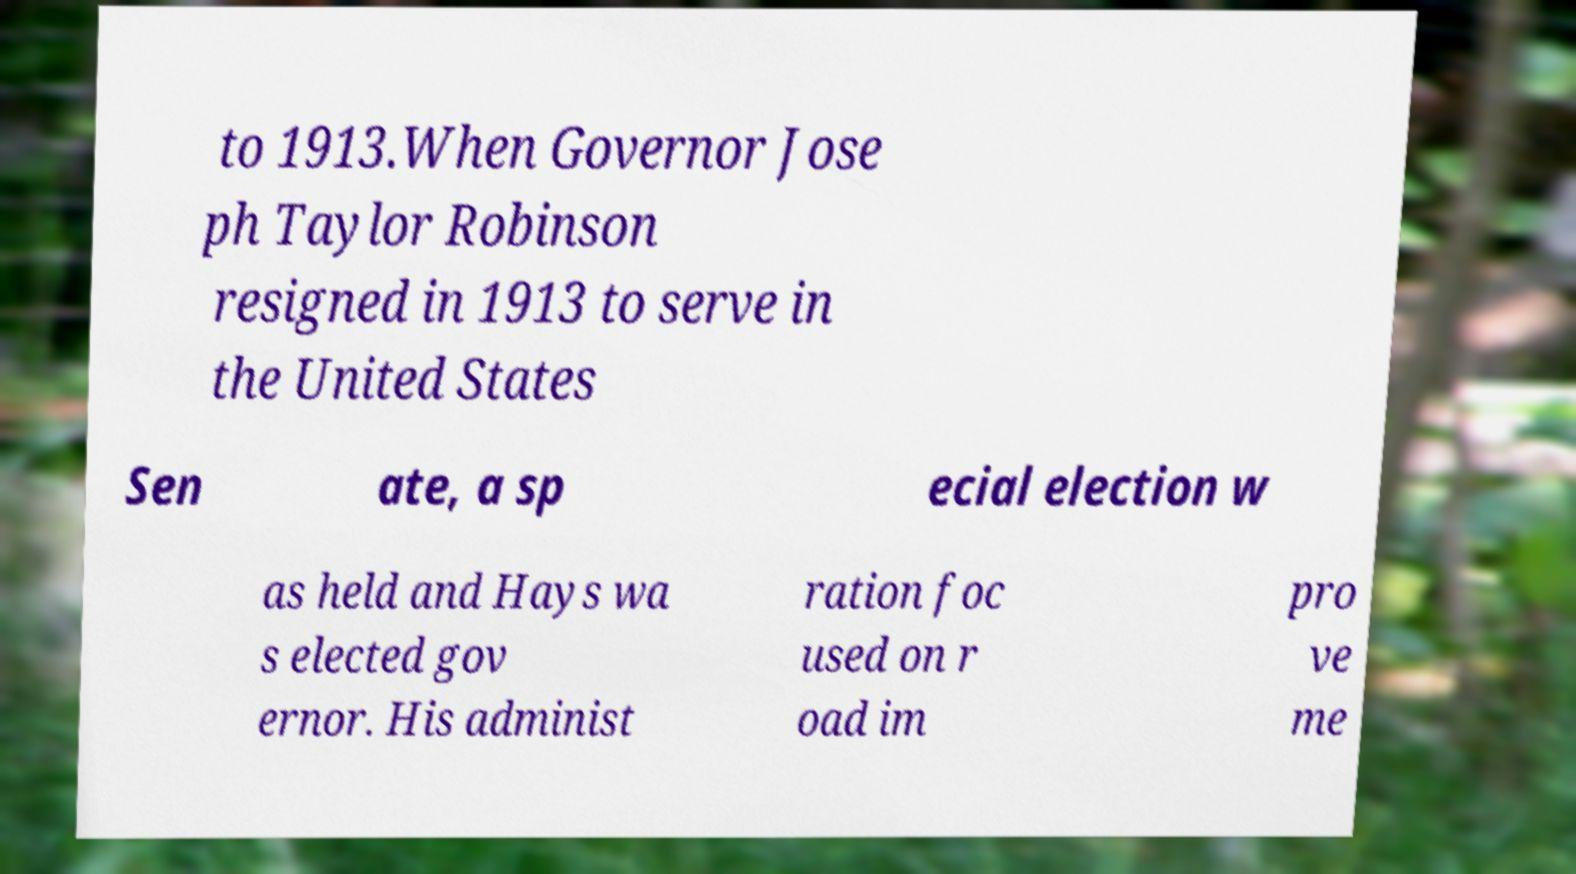Could you assist in decoding the text presented in this image and type it out clearly? to 1913.When Governor Jose ph Taylor Robinson resigned in 1913 to serve in the United States Sen ate, a sp ecial election w as held and Hays wa s elected gov ernor. His administ ration foc used on r oad im pro ve me 